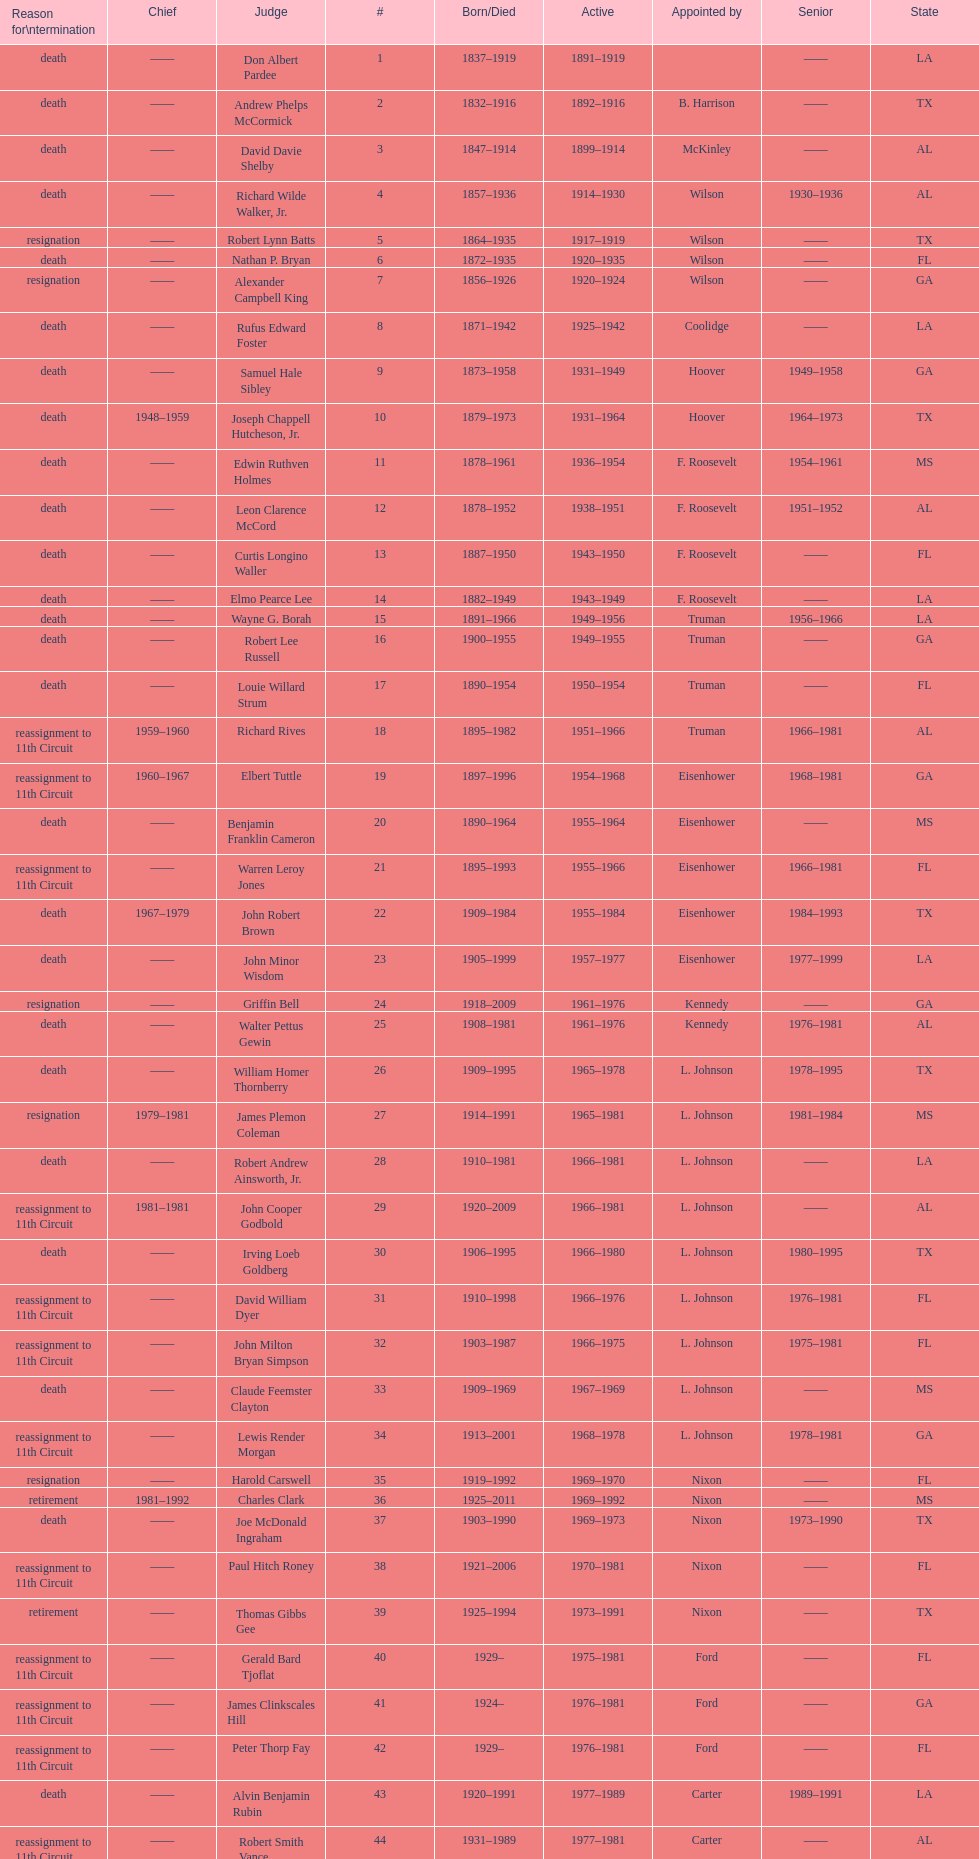Who was the first judge appointed from georgia? Alexander Campbell King. 